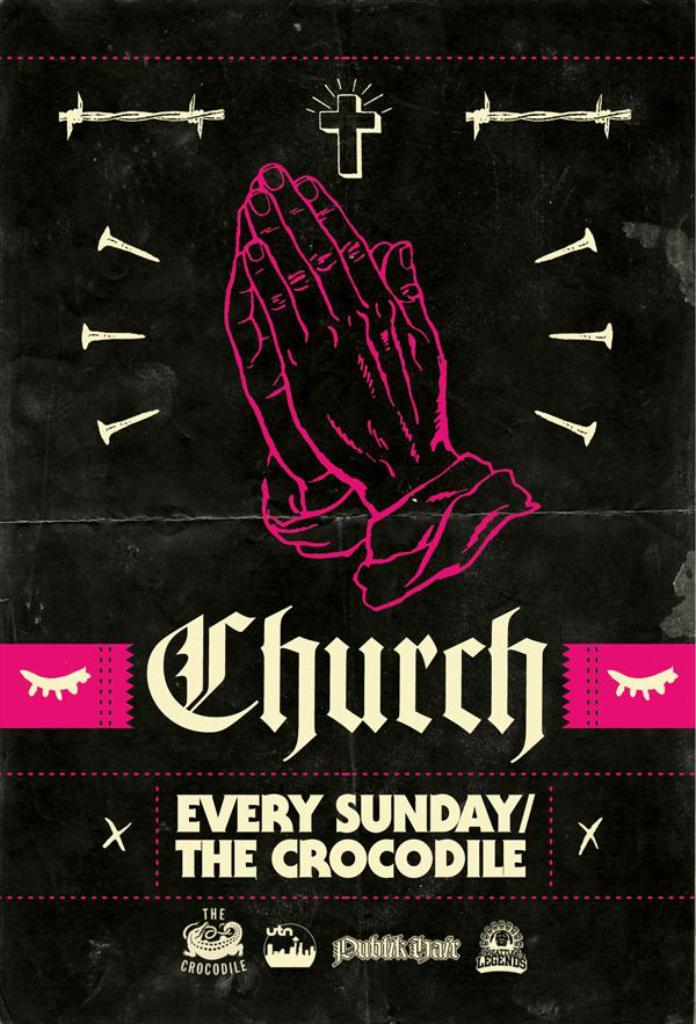Provide a one-sentence caption for the provided image. A flyer advertises Church on Sundays at an establishment called The Crocodile. 